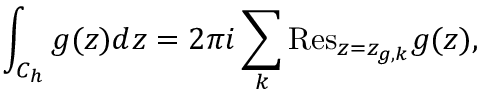Convert formula to latex. <formula><loc_0><loc_0><loc_500><loc_500>\int _ { C _ { h } } { g ( z ) d z } = 2 \pi i \sum _ { k } { R e s } _ { z = z _ { g , k } } g ( z ) ,</formula> 